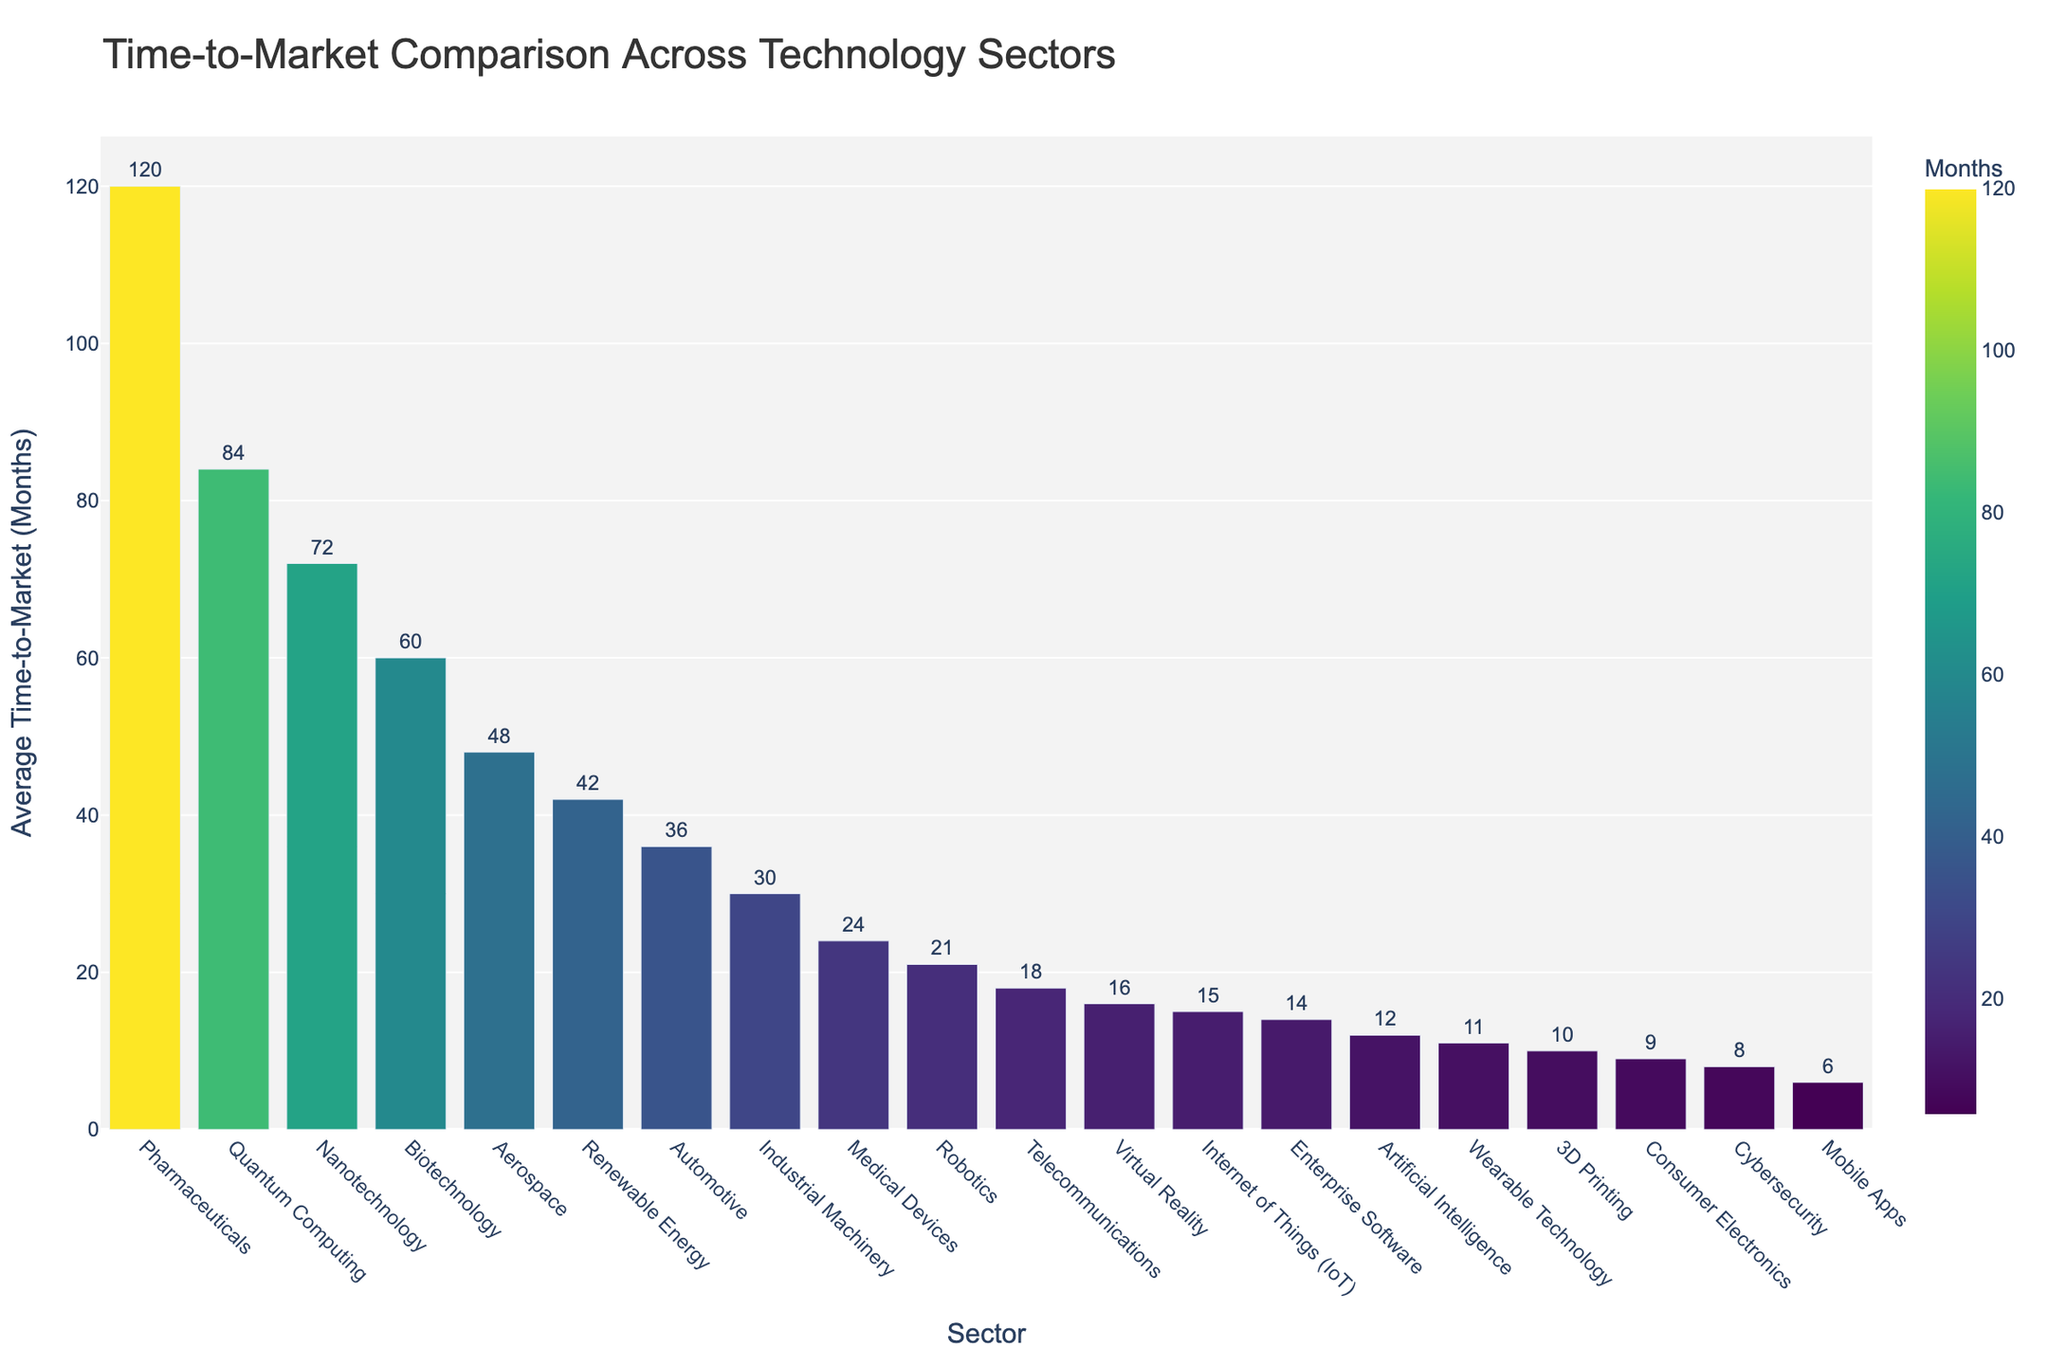Which sector has the longest average time-to-market? Look for the bar with the maximum height. The sector with the longest average time-to-market is labeled on the x-axis.
Answer: Quantum Computing What is the difference in average time-to-market between Aerospace and Telecommunications? Identify the heights of the bars for Aerospace and Telecommunications. Aerospace is 48 months, and Telecommunications is 18 months. Subtract 18 from 48 to find the difference.
Answer: 30 months Which sector has a shorter average time-to-market, Mobile Apps or Consumer Electronics? Compare the heights of the bars for Mobile Apps and Consumer Electronics. Mobile Apps is 6 months and Consumer Electronics is 9 months. Since 6 is less than 9, Mobile Apps has a shorter average time-to-market.
Answer: Mobile Apps What is the range of average time-to-market values across all sectors? Identify the minimum and maximum heights of the bars. The minimum is 6 months (Mobile Apps) and the maximum is 84 months (Quantum Computing). Subtract the minimum from the maximum to find the range.
Answer: 78 months How many sectors have an average time-to-market greater than 30 months? Count the number of bars with heights greater than 30 months. These sectors are Automotive, Pharmaceuticals, Aerospace, Industrial Machinery, Renewable Energy, Biotechnology, Nanotechnology, and Quantum Computing.
Answer: 8 sectors What's the average time-to-market of Consumer Electronics, Medical Devices, and Wearable Technology? Identify the heights of the bars for Consumer Electronics (9 months), Medical Devices (24 months), and Wearable Technology (11 months). Sum these values: 9 + 24 + 11 = 44. Then, divide by 3 to find the average.
Answer: 14.67 months Describe the color gradient progression in the chart. Observe the color of the bars, which change progressively from one end of the spectrum to the other. The bars shift from green for shorter durations to yellow for medium durations and to blue for longer durations.
Answer: Green to Yellow to Blue What is the median time-to-market value in the chart? List all average times-to-market in ascending order: 6, 8, 9, 10, 11, 12, 14, 15, 16, 18, 21, 24, 30, 36, 42, 48, 60, 72, 84, 120. The median is the middle value of the ordered list, which is the 10th value as the total count is 20.
Answer: 18 months 